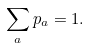<formula> <loc_0><loc_0><loc_500><loc_500>\sum _ { a } p _ { a } = 1 .</formula> 